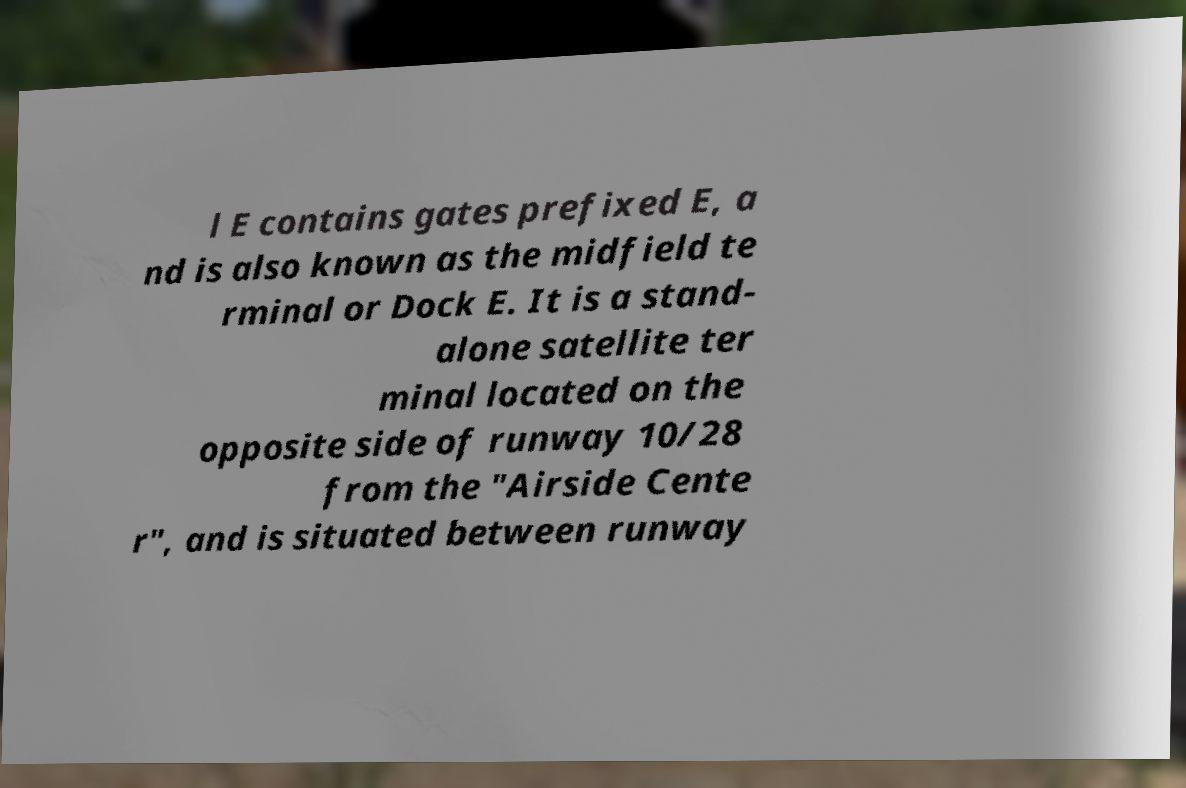For documentation purposes, I need the text within this image transcribed. Could you provide that? l E contains gates prefixed E, a nd is also known as the midfield te rminal or Dock E. It is a stand- alone satellite ter minal located on the opposite side of runway 10/28 from the "Airside Cente r", and is situated between runway 